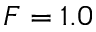<formula> <loc_0><loc_0><loc_500><loc_500>F = 1 . 0</formula> 